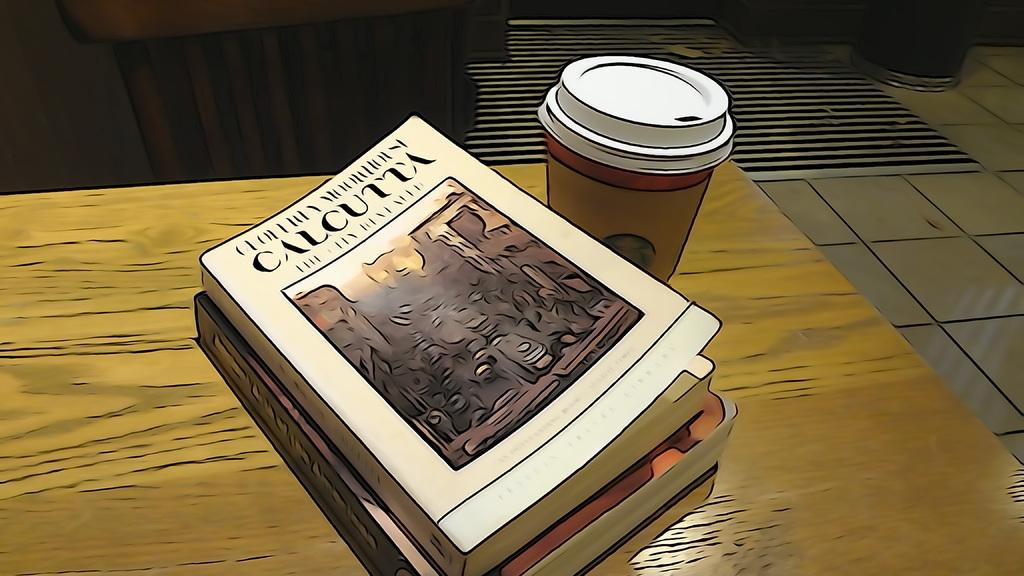What type of objects can be seen in the image? There are books and a glass on a wooden table in the image. Where is the glass located in the image? The glass is on a wooden table in the image. What is present on the top right side of the image? There is an object on the top right side of the image. What type of flooring is visible in the image? The floor appears to have a carpet in the image. Can you see a crook in the image? No, there is no crook present in the image. 